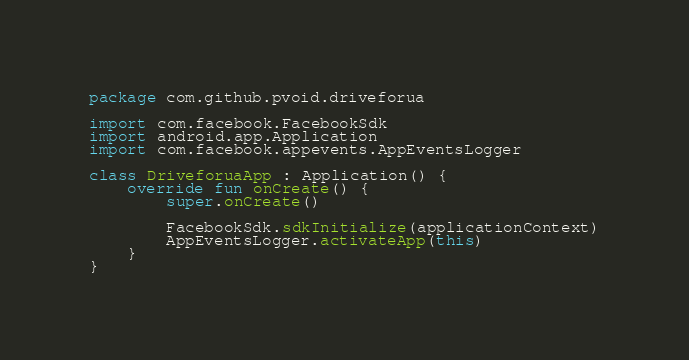Convert code to text. <code><loc_0><loc_0><loc_500><loc_500><_Kotlin_>package com.github.pvoid.driveforua

import com.facebook.FacebookSdk
import android.app.Application
import com.facebook.appevents.AppEventsLogger

class DriveforuaApp : Application() {
    override fun onCreate() {
        super.onCreate()

        FacebookSdk.sdkInitialize(applicationContext)
        AppEventsLogger.activateApp(this)
    }
}</code> 